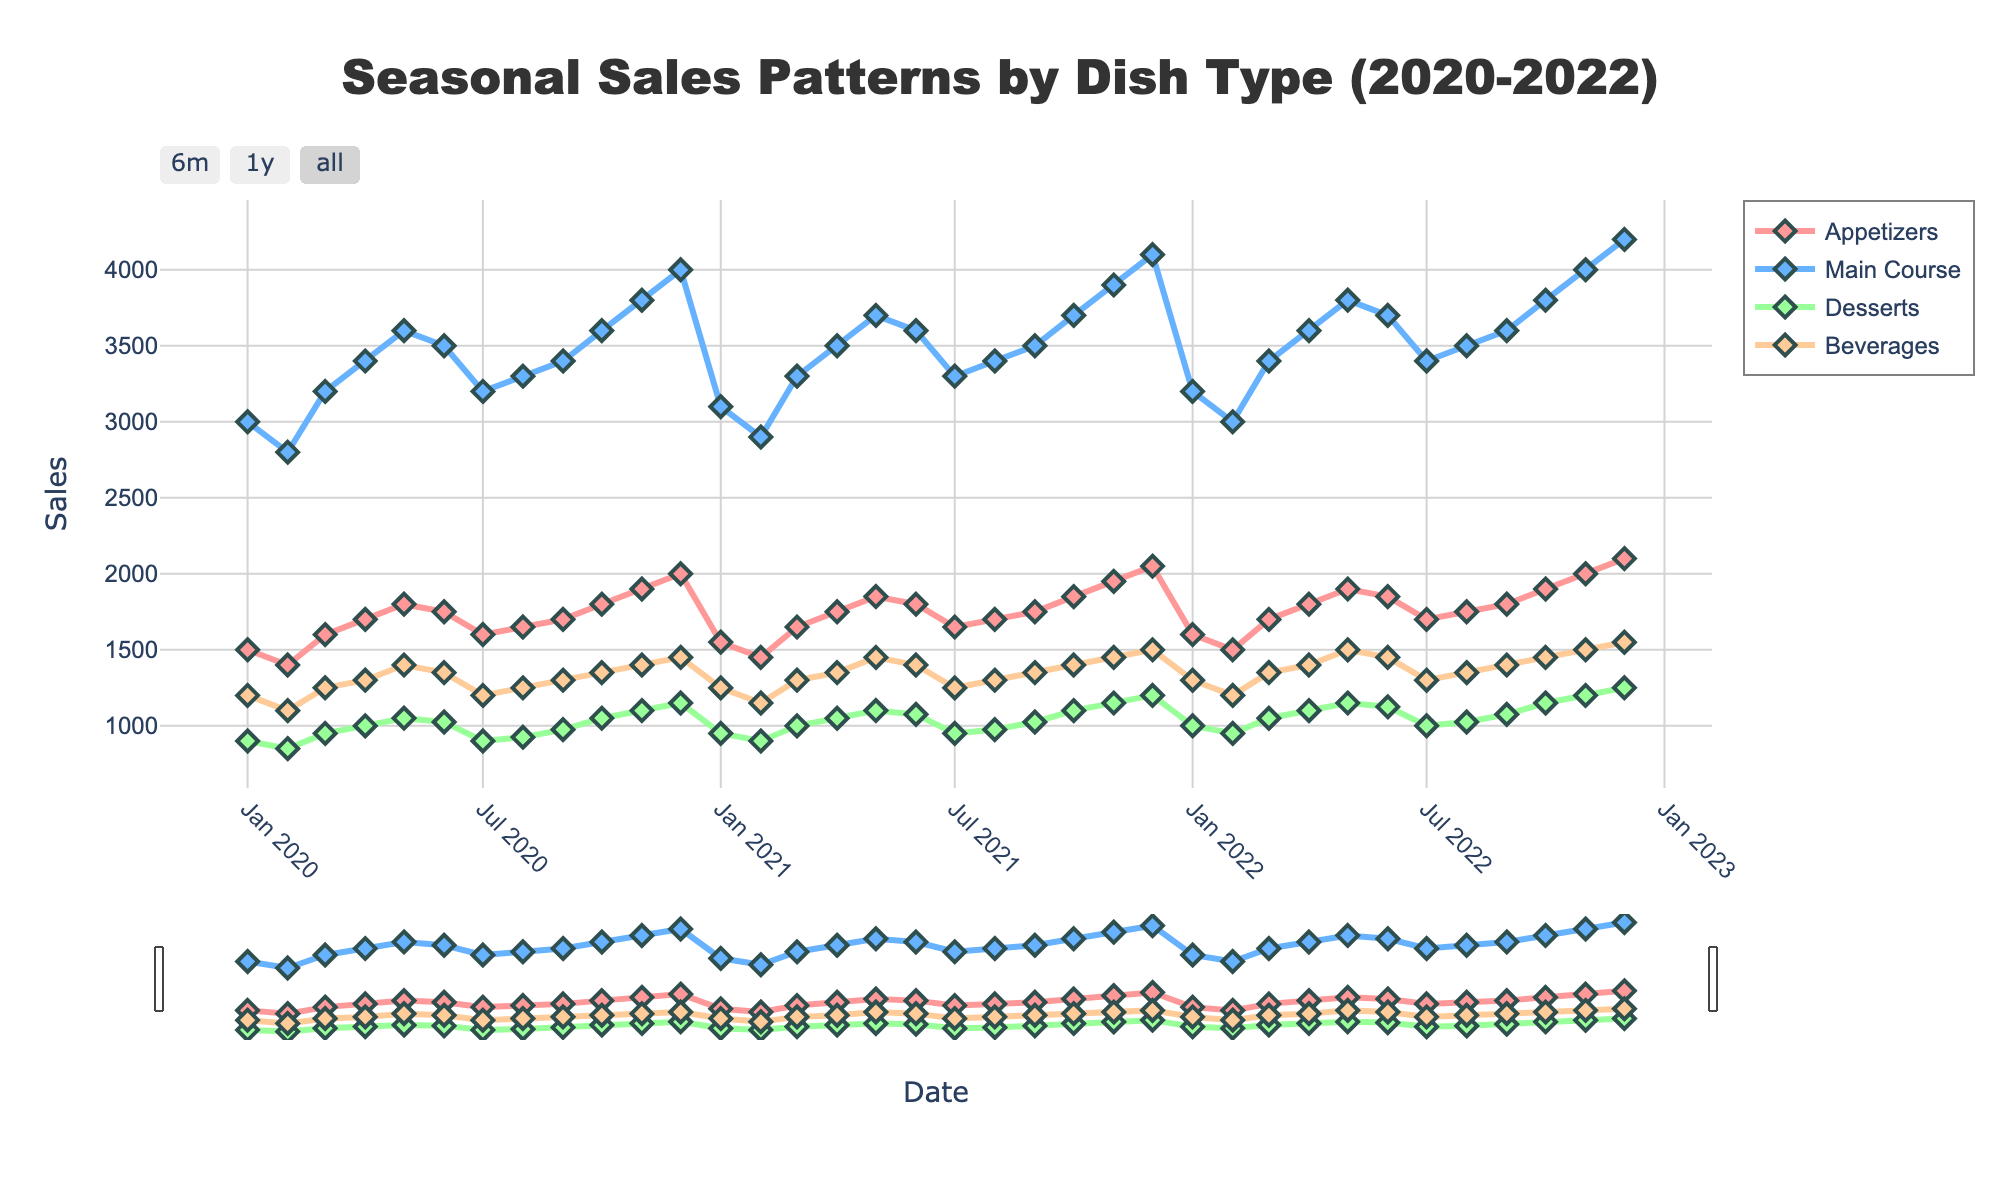What's the average monthly sales for Main Course in 2022? To find the average, sum the monthly sales figures for Main Course in 2022, then divide by 12 (the number of months). The sales figures are: 3200, 3000, 3400, 3600, 3800, 3700, 3400, 3500, 3600, 3800, 4000, 4200. The sum is 44200. So, 44200/12 equals approximately 3683.33
Answer: 3683.33 Which month had the highest sales for Desserts in 2021, and what was the value? First, look at the monthly sales figures for Desserts in 2021: 950, 900, 1000, 1050, 1100, 1075, 950, 975, 1025, 1100, 1150, 1200. The highest value is 1200, which occurs in December 2021.
Answer: December 2021, 1200 How did sales for Beverages change from January 2020 to December 2022? Sales for Beverages in January 2020 were 1200, and in December 2022, they were 1550. To find the change, subtract the January 2020 value from the December 2022 value: 1550 - 1200 equals 350.
Answer: Increased by 350 Across all years, during which month do Main Course sales consistently peak? By observing the line trends for Main Course sales from the visual, it consistently peaks in December for each year.
Answer: December In which year did Appetizers have the highest average monthly sales? Calculate the average monthly sales for Appetizers for each year. Sum the figures for 2020 (1500+1400+1600+1700+1800+1750+1600+1650+1700+1800+1900+2000 = 21000), 2021 (1550+1450+1650+1750+1850+1800+1650+1700+1750+1850+1950+2050 = 21850), and 2022 (1600+1500+1700+1800+1900+1850+1700+1750+1800+1900+2000+2100 = 22650), then divide by 12. The highest average occurs in 2022.
Answer: 2022 What is the pattern of sales for Beverages during the summer months (June, July, August) across the three years? Extract sales for June, July, August from each year. For 2020: 1350, 1200, 1250. For 2021: 1400, 1250, 1300. For 2022: 1450, 1300, 1350. Sales trend slightly upwards each summer, peaking in June and then decreasing.
Answer: Slight upward trend with peak in June Does any dish type show a significant dip in sales during a specific month across the years? Reviewing the lines, Main Course shows a dip each July across all three years.
Answer: Main Course in July What was the total sales for Desserts in 2021? Sum the monthly sales figures for Desserts in 2021: 950 + 900 + 1000 + 1050 + 1100 + 1075 + 950 + 975 + 1025 + 1100 + 1150 + 1200 = 13475.
Answer: 13475 Which dish type had the most consistent sales pattern over the three years? Look at all dish types' lines; Appetizers have the least variation and most consistent pattern across all months for three years.
Answer: Appetizers 